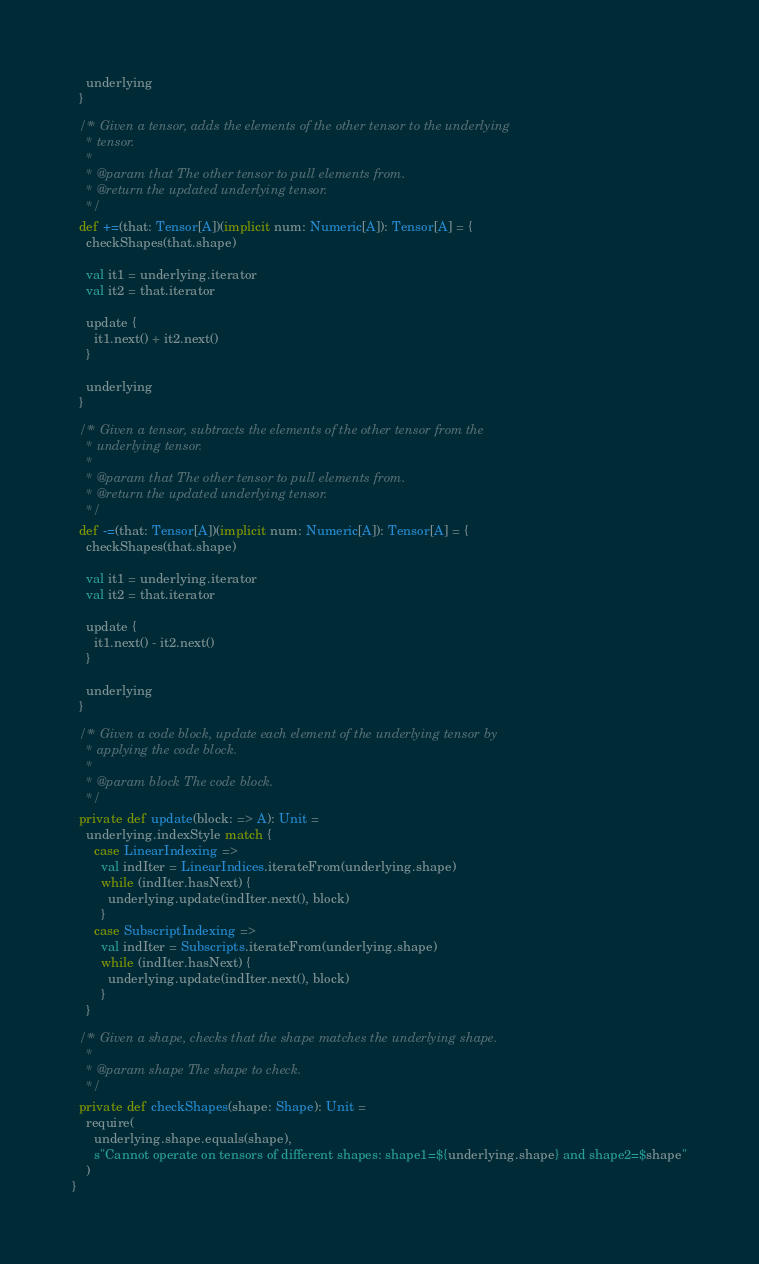Convert code to text. <code><loc_0><loc_0><loc_500><loc_500><_Scala_>    underlying
  }

  /** Given a tensor, adds the elements of the other tensor to the underlying
    * tensor.
    *
    * @param that The other tensor to pull elements from.
    * @return the updated underlying tensor.
    */
  def +=(that: Tensor[A])(implicit num: Numeric[A]): Tensor[A] = {
    checkShapes(that.shape)

    val it1 = underlying.iterator
    val it2 = that.iterator

    update {
      it1.next() + it2.next()
    }

    underlying
  }

  /** Given a tensor, subtracts the elements of the other tensor from the
    * underlying tensor.
    *
    * @param that The other tensor to pull elements from.
    * @return the updated underlying tensor.
    */
  def -=(that: Tensor[A])(implicit num: Numeric[A]): Tensor[A] = {
    checkShapes(that.shape)

    val it1 = underlying.iterator
    val it2 = that.iterator

    update {
      it1.next() - it2.next()
    }

    underlying
  }

  /** Given a code block, update each element of the underlying tensor by
    * applying the code block.
    *
    * @param block The code block.
    */
  private def update(block: => A): Unit =
    underlying.indexStyle match {
      case LinearIndexing =>
        val indIter = LinearIndices.iterateFrom(underlying.shape)
        while (indIter.hasNext) {
          underlying.update(indIter.next(), block)
        }
      case SubscriptIndexing =>
        val indIter = Subscripts.iterateFrom(underlying.shape)
        while (indIter.hasNext) {
          underlying.update(indIter.next(), block)
        }
    }

  /** Given a shape, checks that the shape matches the underlying shape.
    *
    * @param shape The shape to check.
    */
  private def checkShapes(shape: Shape): Unit =
    require(
      underlying.shape.equals(shape),
      s"Cannot operate on tensors of different shapes: shape1=${underlying.shape} and shape2=$shape"
    )
}
</code> 